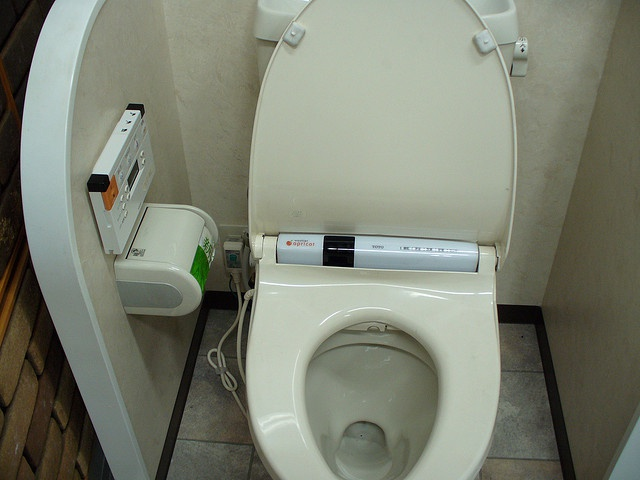Describe the objects in this image and their specific colors. I can see a toilet in black, darkgray, lightgray, and gray tones in this image. 